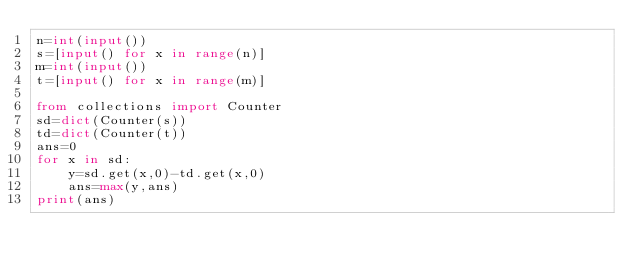Convert code to text. <code><loc_0><loc_0><loc_500><loc_500><_Python_>n=int(input())
s=[input() for x in range(n)]
m=int(input())
t=[input() for x in range(m)]

from collections import Counter
sd=dict(Counter(s))
td=dict(Counter(t))
ans=0
for x in sd:
    y=sd.get(x,0)-td.get(x,0)
    ans=max(y,ans)
print(ans)</code> 